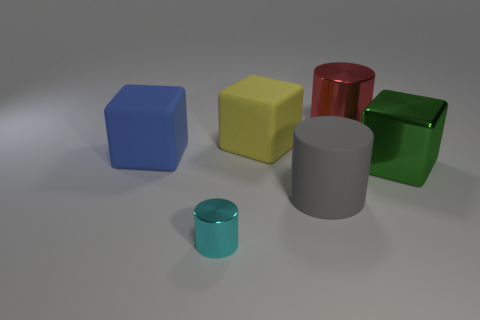What is the blue cube made of?
Your answer should be compact. Rubber. What is the block that is both in front of the yellow block and on the right side of the small cyan object made of?
Give a very brief answer. Metal. What number of objects are big metallic cylinders behind the cyan metallic thing or gray metallic things?
Your response must be concise. 1. Is the small metallic object the same color as the shiny block?
Ensure brevity in your answer.  No. Are there any metal objects that have the same size as the blue matte cube?
Your answer should be compact. Yes. How many objects are on the left side of the large red thing and right of the yellow block?
Give a very brief answer. 1. There is a blue matte block; how many red metal cylinders are in front of it?
Keep it short and to the point. 0. Are there any red shiny objects that have the same shape as the small cyan object?
Keep it short and to the point. Yes. Is the shape of the yellow object the same as the metallic thing that is left of the gray cylinder?
Your response must be concise. No. How many blocks are either blue rubber things or tiny brown matte objects?
Ensure brevity in your answer.  1. 